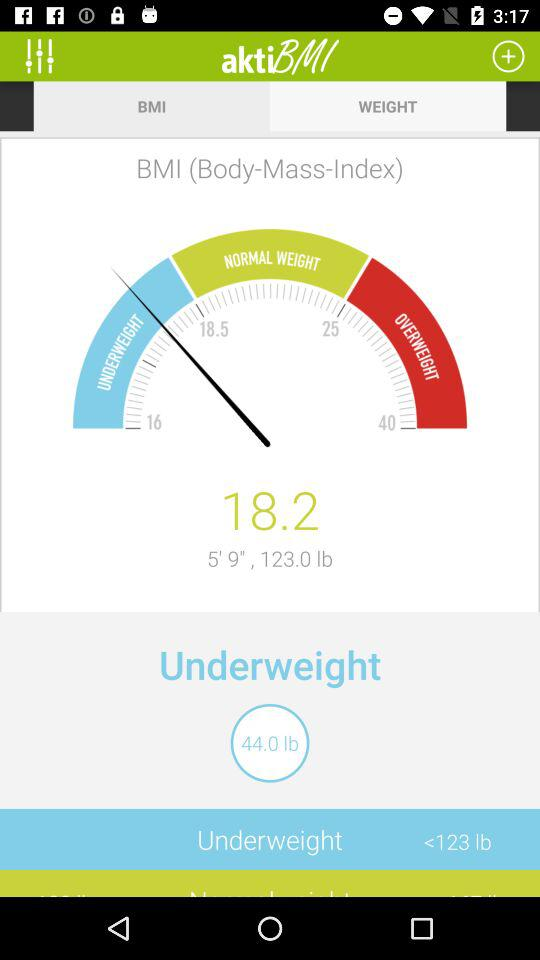What is the height? The height is 5 feet 9 inches. 